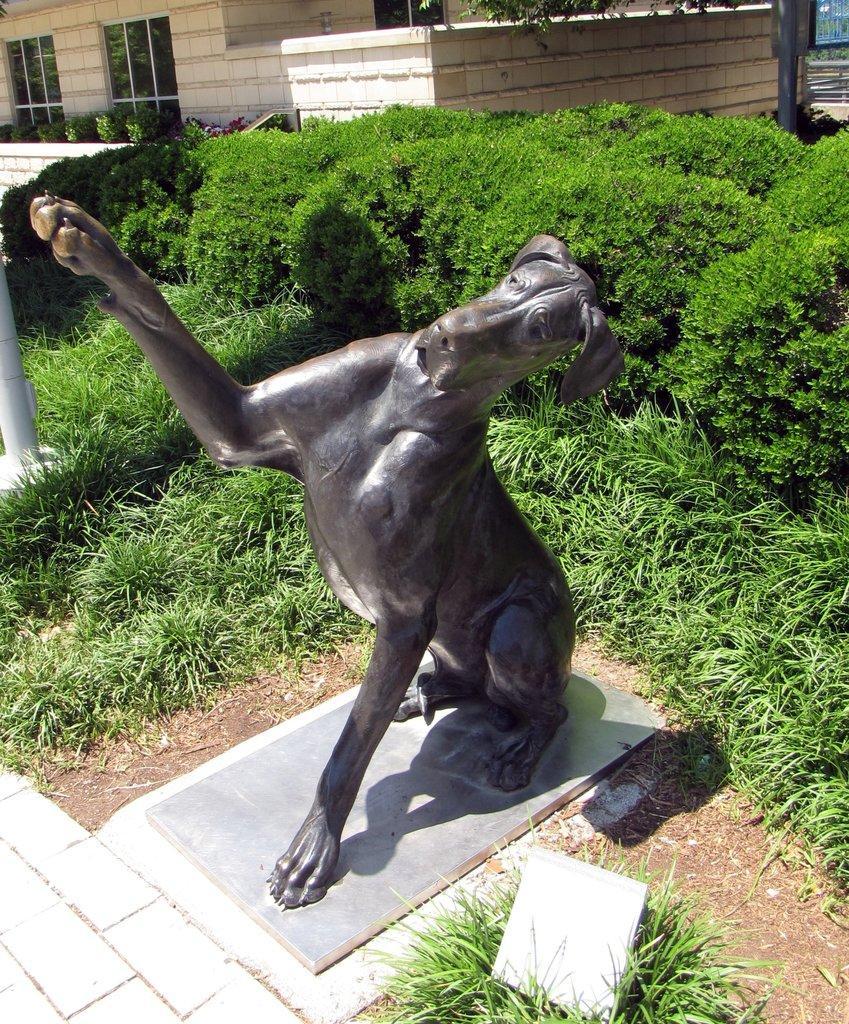Can you describe this image briefly? In this picture we can see the statue of an animal. Behind the statue there are plants, poles, wall and it is looking like a house. 